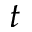Convert formula to latex. <formula><loc_0><loc_0><loc_500><loc_500>t</formula> 